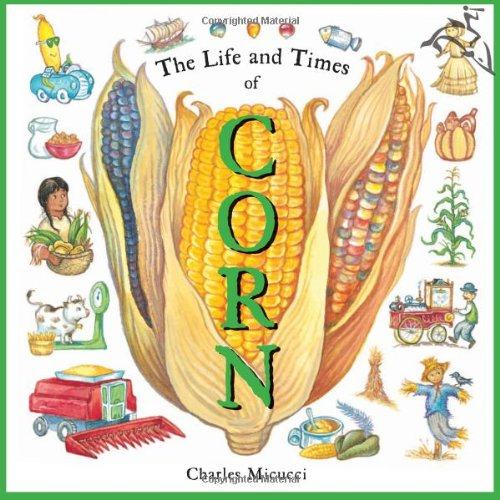What might children learn about the cultural significance of corn from this book? Children can learn about corn's role in different cultures, especially in Native American agriculture, its use in various traditional dishes, and its cultural symbolism in harvest festivals. 